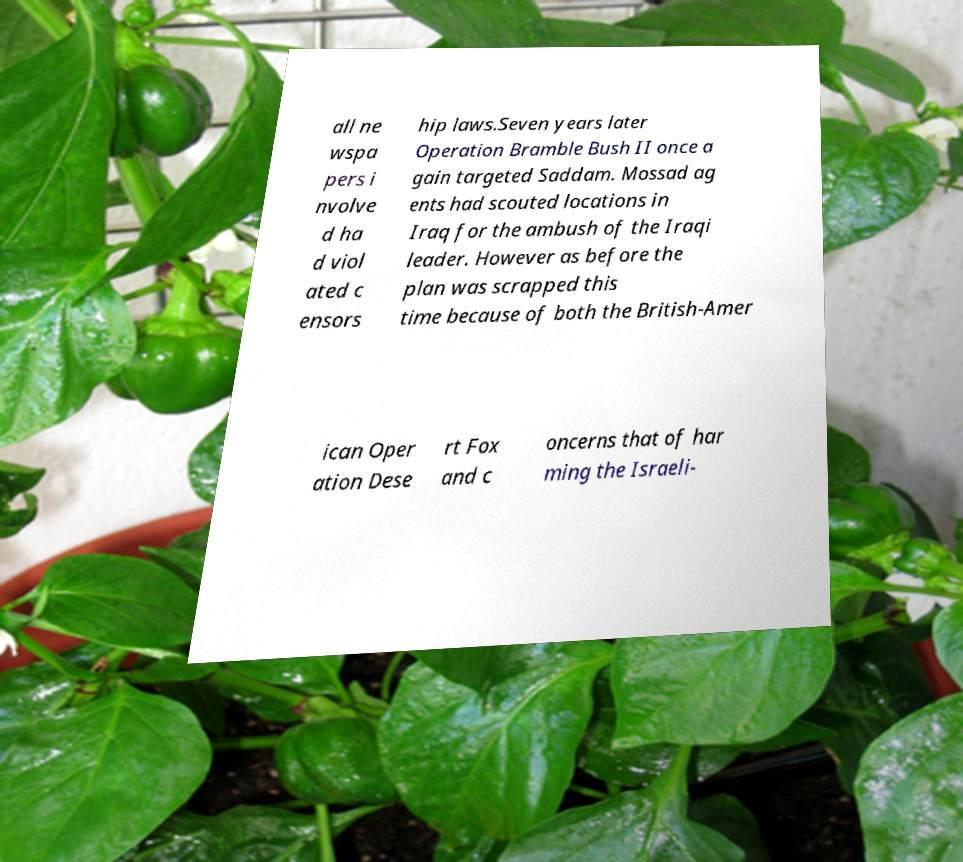Please identify and transcribe the text found in this image. all ne wspa pers i nvolve d ha d viol ated c ensors hip laws.Seven years later Operation Bramble Bush II once a gain targeted Saddam. Mossad ag ents had scouted locations in Iraq for the ambush of the Iraqi leader. However as before the plan was scrapped this time because of both the British-Amer ican Oper ation Dese rt Fox and c oncerns that of har ming the Israeli- 